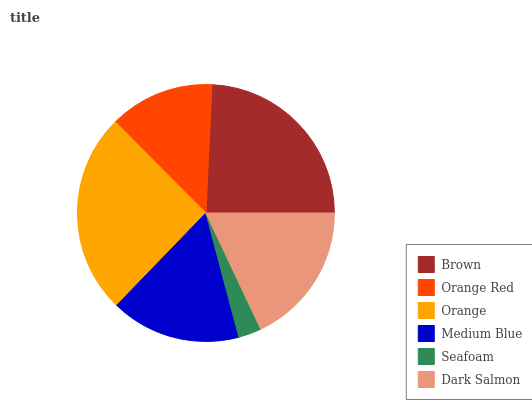Is Seafoam the minimum?
Answer yes or no. Yes. Is Orange the maximum?
Answer yes or no. Yes. Is Orange Red the minimum?
Answer yes or no. No. Is Orange Red the maximum?
Answer yes or no. No. Is Brown greater than Orange Red?
Answer yes or no. Yes. Is Orange Red less than Brown?
Answer yes or no. Yes. Is Orange Red greater than Brown?
Answer yes or no. No. Is Brown less than Orange Red?
Answer yes or no. No. Is Dark Salmon the high median?
Answer yes or no. Yes. Is Medium Blue the low median?
Answer yes or no. Yes. Is Orange Red the high median?
Answer yes or no. No. Is Seafoam the low median?
Answer yes or no. No. 